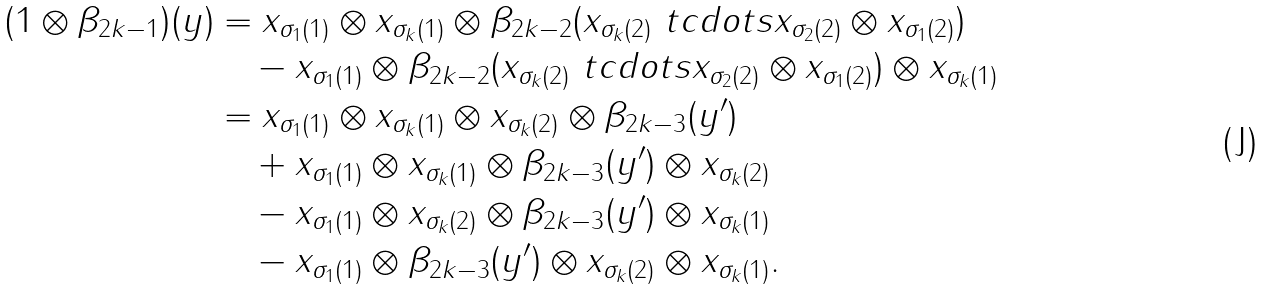<formula> <loc_0><loc_0><loc_500><loc_500>( 1 \otimes \beta _ { 2 k - 1 } ) ( y ) & = x _ { \sigma _ { 1 } ( 1 ) } \otimes x _ { \sigma _ { k } ( 1 ) } \otimes \beta _ { 2 k - 2 } ( x _ { \sigma _ { k } ( 2 ) } \ t c d o t s x _ { \sigma _ { 2 } ( 2 ) } \otimes x _ { \sigma _ { 1 } ( 2 ) } ) \\ & \quad - x _ { \sigma _ { 1 } ( 1 ) } \otimes \beta _ { 2 k - 2 } ( x _ { \sigma _ { k } ( 2 ) } \ t c d o t s x _ { \sigma _ { 2 } ( 2 ) } \otimes x _ { \sigma _ { 1 } ( 2 ) } ) \otimes x _ { \sigma _ { k } ( 1 ) } \\ & = x _ { \sigma _ { 1 } ( 1 ) } \otimes x _ { \sigma _ { k } ( 1 ) } \otimes x _ { \sigma _ { k } ( 2 ) } \otimes \beta _ { 2 k - 3 } ( y ^ { \prime } ) \\ & \quad + x _ { \sigma _ { 1 } ( 1 ) } \otimes x _ { \sigma _ { k } ( 1 ) } \otimes \beta _ { 2 k - 3 } ( y ^ { \prime } ) \otimes x _ { \sigma _ { k } ( 2 ) } \\ & \quad - x _ { \sigma _ { 1 } ( 1 ) } \otimes x _ { \sigma _ { k } ( 2 ) } \otimes \beta _ { 2 k - 3 } ( y ^ { \prime } ) \otimes x _ { \sigma _ { k } ( 1 ) } \\ & \quad - x _ { \sigma _ { 1 } ( 1 ) } \otimes \beta _ { 2 k - 3 } ( y ^ { \prime } ) \otimes x _ { \sigma _ { k } ( 2 ) } \otimes x _ { \sigma _ { k } ( 1 ) } .</formula> 